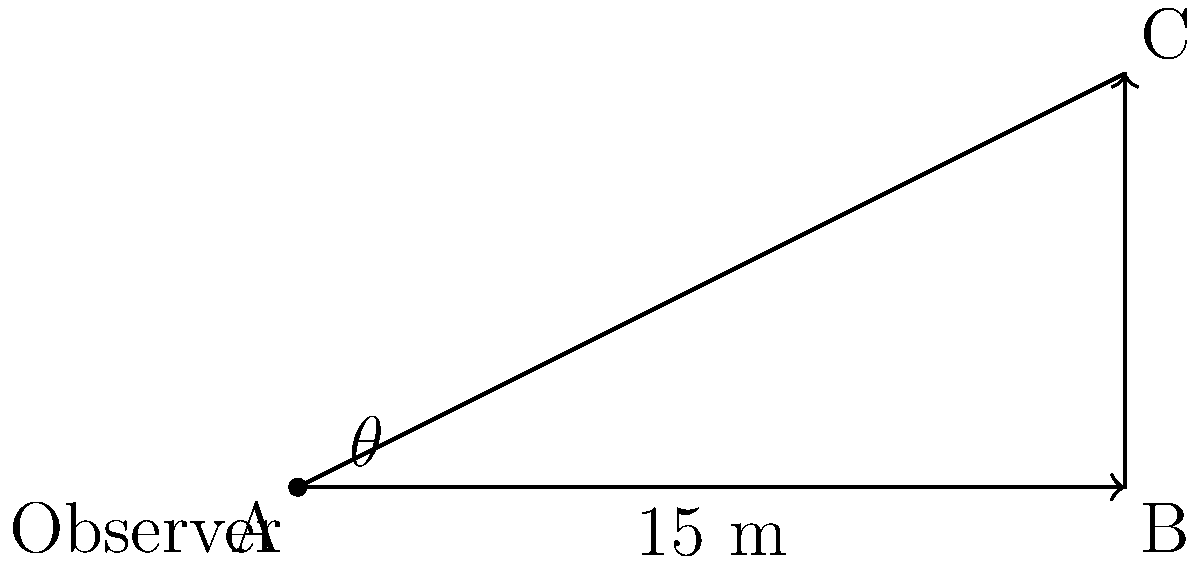Professor Urquhart, in one of his classic trigonometry problems, presents a scenario where an observer stands 15 meters away from the base of a building. The observer's line of sight to the top of the building forms a right-angled triangle. If the height of the building is 3 meters, what is the angle of elevation ($\theta$) from the observer to the top of the building? Let's approach this step-by-step, as Professor Urquhart would have taught:

1) We have a right-angled triangle where:
   - The adjacent side (distance from observer to building) is 15 meters
   - The opposite side (height of the building) is 3 meters
   - We need to find the angle $\theta$

2) In a right-angled triangle, tangent of an angle is the ratio of the opposite side to the adjacent side:

   $\tan \theta = \frac{\text{opposite}}{\text{adjacent}}$

3) Substituting our known values:

   $\tan \theta = \frac{3}{15}$

4) Simplify the fraction:

   $\tan \theta = \frac{1}{5} = 0.2$

5) To find $\theta$, we need to use the inverse tangent (arctan or $\tan^{-1}$):

   $\theta = \tan^{-1}(0.2)$

6) Using a calculator or trigonometric tables (as Professor Urquhart might have insisted):

   $\theta \approx 11.31°$

7) Rounding to the nearest degree:

   $\theta \approx 11°$
Answer: $11°$ 